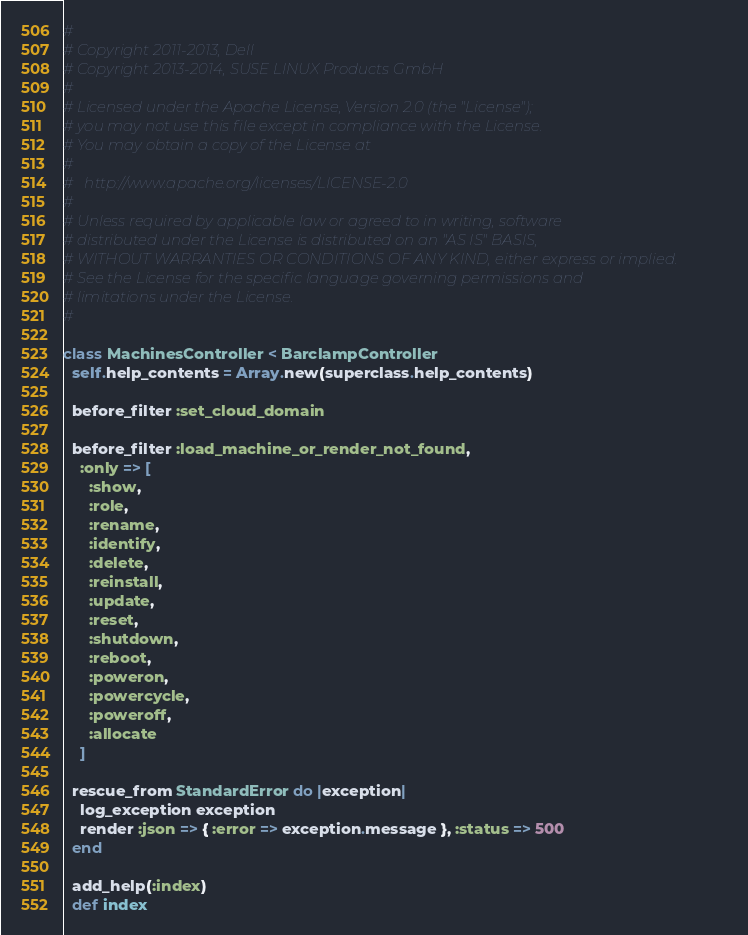<code> <loc_0><loc_0><loc_500><loc_500><_Ruby_>#
# Copyright 2011-2013, Dell
# Copyright 2013-2014, SUSE LINUX Products GmbH
#
# Licensed under the Apache License, Version 2.0 (the "License");
# you may not use this file except in compliance with the License.
# You may obtain a copy of the License at
#
#   http://www.apache.org/licenses/LICENSE-2.0
#
# Unless required by applicable law or agreed to in writing, software
# distributed under the License is distributed on an "AS IS" BASIS,
# WITHOUT WARRANTIES OR CONDITIONS OF ANY KIND, either express or implied.
# See the License for the specific language governing permissions and
# limitations under the License.
#

class MachinesController < BarclampController
  self.help_contents = Array.new(superclass.help_contents)

  before_filter :set_cloud_domain

  before_filter :load_machine_or_render_not_found,
    :only => [
      :show,
      :role,
      :rename,
      :identify,
      :delete,
      :reinstall,
      :update,
      :reset,
      :shutdown,
      :reboot,
      :poweron,
      :powercycle,
      :poweroff,
      :allocate
    ]

  rescue_from StandardError do |exception|
    log_exception exception
    render :json => { :error => exception.message }, :status => 500
  end

  add_help(:index)
  def index</code> 